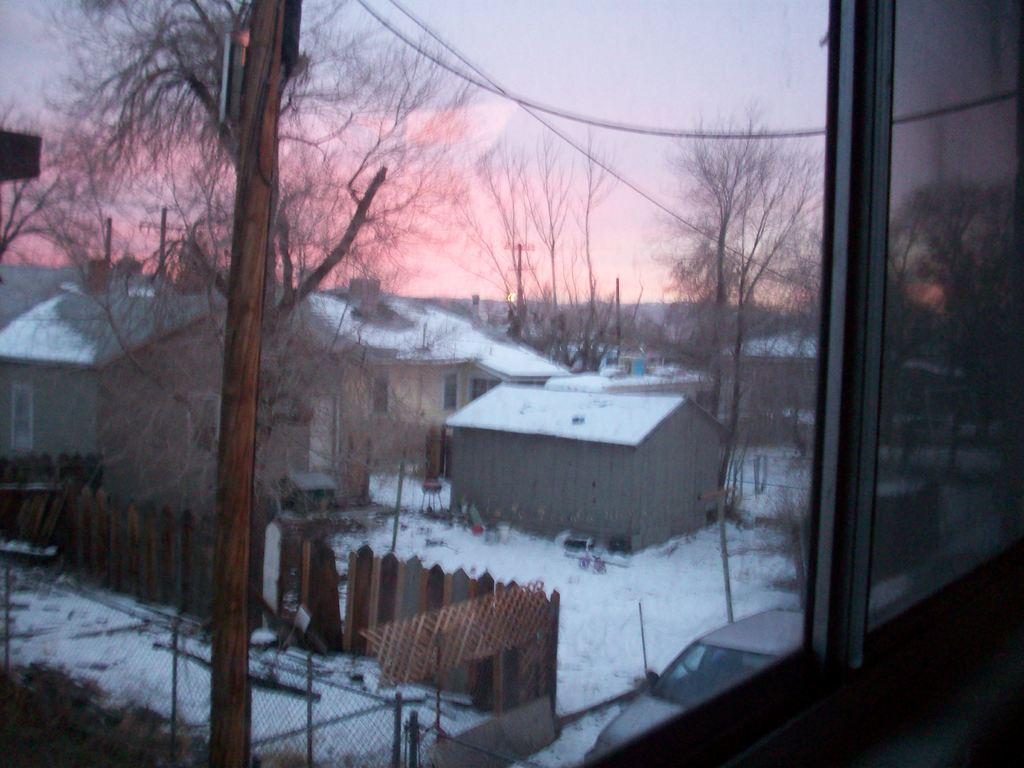What material is present in the image? There is glass in the image. What can be seen through the glass? Houses, snow, a fence, trees, mesh, poles, and the sky are visible through the glass. What type of idea can be seen flying through the image? There is no idea present in the image, as ideas are abstract concepts and cannot be seen. 